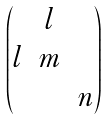Convert formula to latex. <formula><loc_0><loc_0><loc_500><loc_500>\begin{pmatrix} & l & \\ l & m & \\ & & n \end{pmatrix}</formula> 